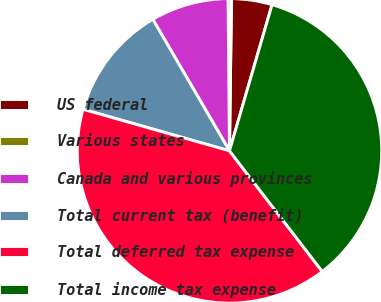Convert chart. <chart><loc_0><loc_0><loc_500><loc_500><pie_chart><fcel>US federal<fcel>Various states<fcel>Canada and various provinces<fcel>Total current tax (benefit)<fcel>Total deferred tax expense<fcel>Total income tax expense<nl><fcel>4.3%<fcel>0.36%<fcel>8.25%<fcel>12.2%<fcel>39.83%<fcel>35.06%<nl></chart> 